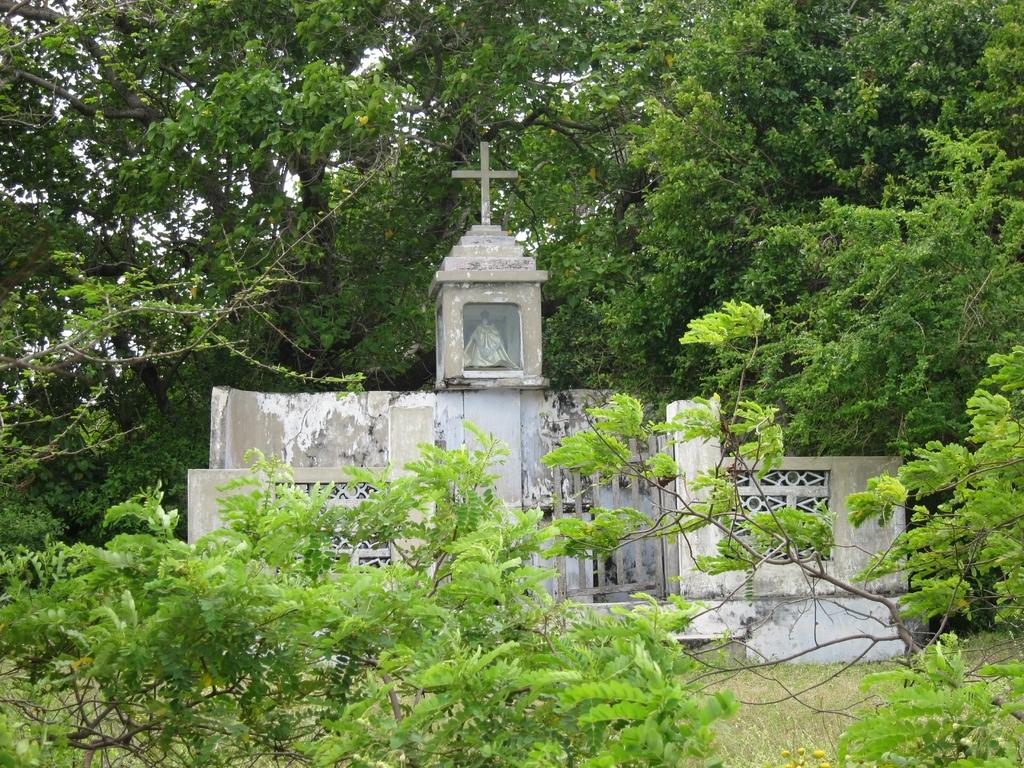What is the main subject in the center of the image? There is a cemetery gate and a cross in the center of the image. What can be seen in the background of the image? There are trees in the background of the image. What type of vegetation is present at the bottom of the image? There are plants and grass at the bottom of the image. What color is the lipstick worn by the person in the image? There is no person wearing lipstick present in the image; it features a cemetery gate, a cross, trees, plants, and grass. 